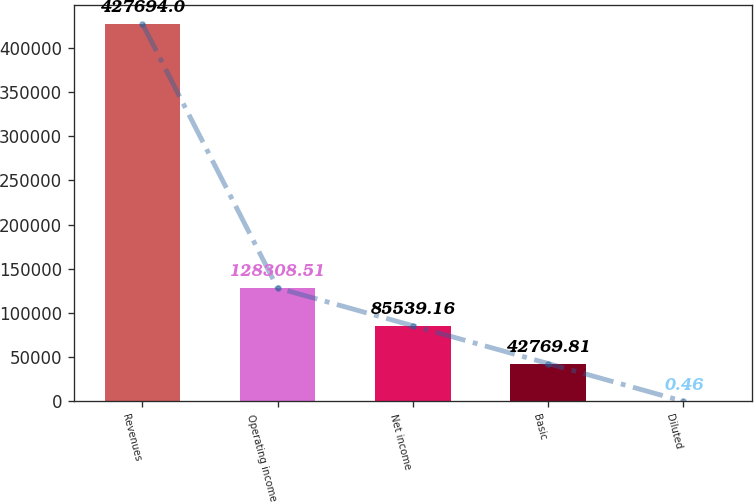Convert chart to OTSL. <chart><loc_0><loc_0><loc_500><loc_500><bar_chart><fcel>Revenues<fcel>Operating income<fcel>Net income<fcel>Basic<fcel>Diluted<nl><fcel>427694<fcel>128309<fcel>85539.2<fcel>42769.8<fcel>0.46<nl></chart> 